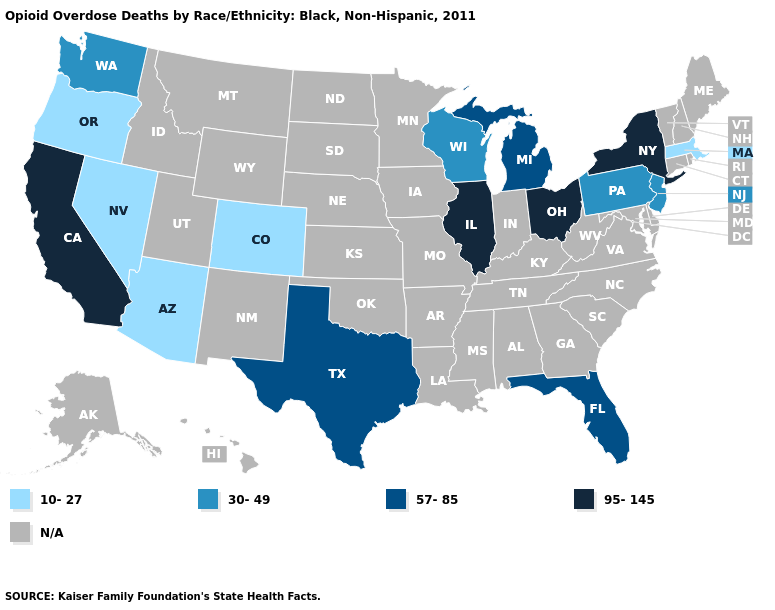What is the value of West Virginia?
Concise answer only. N/A. Name the states that have a value in the range 57-85?
Answer briefly. Florida, Michigan, Texas. Name the states that have a value in the range 30-49?
Short answer required. New Jersey, Pennsylvania, Washington, Wisconsin. What is the highest value in the Northeast ?
Give a very brief answer. 95-145. Does the map have missing data?
Short answer required. Yes. Is the legend a continuous bar?
Answer briefly. No. Name the states that have a value in the range N/A?
Answer briefly. Alabama, Alaska, Arkansas, Connecticut, Delaware, Georgia, Hawaii, Idaho, Indiana, Iowa, Kansas, Kentucky, Louisiana, Maine, Maryland, Minnesota, Mississippi, Missouri, Montana, Nebraska, New Hampshire, New Mexico, North Carolina, North Dakota, Oklahoma, Rhode Island, South Carolina, South Dakota, Tennessee, Utah, Vermont, Virginia, West Virginia, Wyoming. Name the states that have a value in the range 57-85?
Answer briefly. Florida, Michigan, Texas. What is the highest value in states that border Oklahoma?
Answer briefly. 57-85. Does Massachusetts have the lowest value in the Northeast?
Write a very short answer. Yes. Is the legend a continuous bar?
Keep it brief. No. Which states have the lowest value in the Northeast?
Answer briefly. Massachusetts. Which states have the lowest value in the Northeast?
Short answer required. Massachusetts. Name the states that have a value in the range 57-85?
Answer briefly. Florida, Michigan, Texas. What is the value of Connecticut?
Be succinct. N/A. 